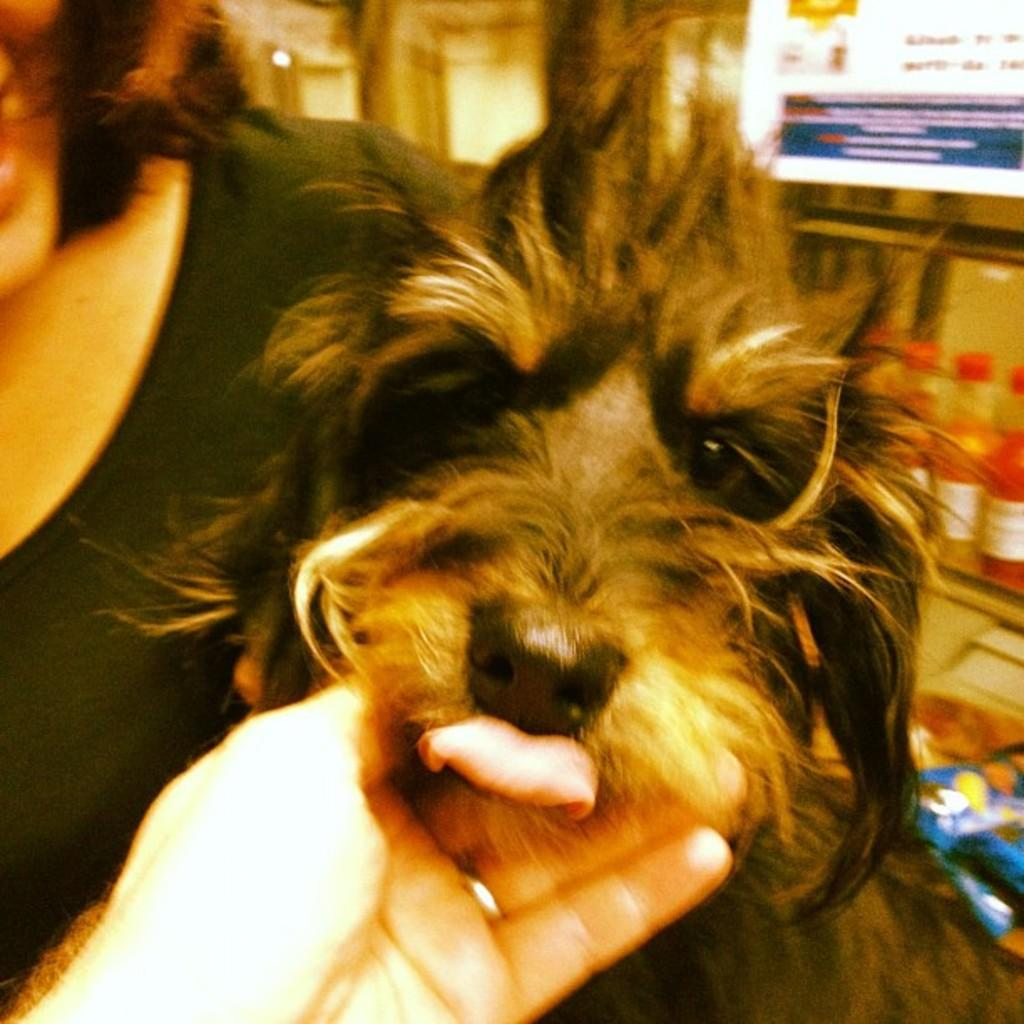Who or what is the main subject in the image? There is a person in the image. What other living creature is present in the image? There is a dog in the image. What objects can be seen in the image besides the person and the dog? There are bottles visible in the image. Can you describe the appearance of some objects in the image? There are blurred objects in the image. What part of the person's body is visible at the bottom of the image? A person's hand is present at the bottom of the image. What is the person's aunt writing on the foggy window in the image? There is no aunt or foggy window present in the image. 